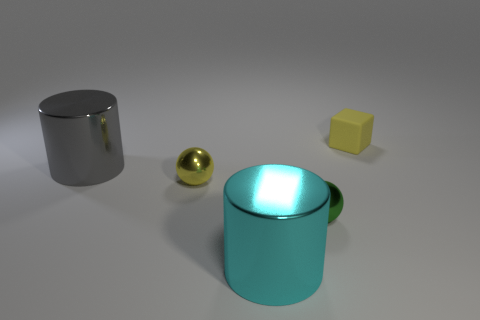Add 4 cyan cylinders. How many objects exist? 9 Subtract all cubes. How many objects are left? 4 Subtract all cyan cylinders. How many cylinders are left? 1 Subtract all small green matte cylinders. Subtract all big cyan shiny cylinders. How many objects are left? 4 Add 2 tiny objects. How many tiny objects are left? 5 Add 3 large gray shiny things. How many large gray shiny things exist? 4 Subtract 0 red cubes. How many objects are left? 5 Subtract 1 spheres. How many spheres are left? 1 Subtract all green cylinders. Subtract all gray blocks. How many cylinders are left? 2 Subtract all yellow balls. How many green cylinders are left? 0 